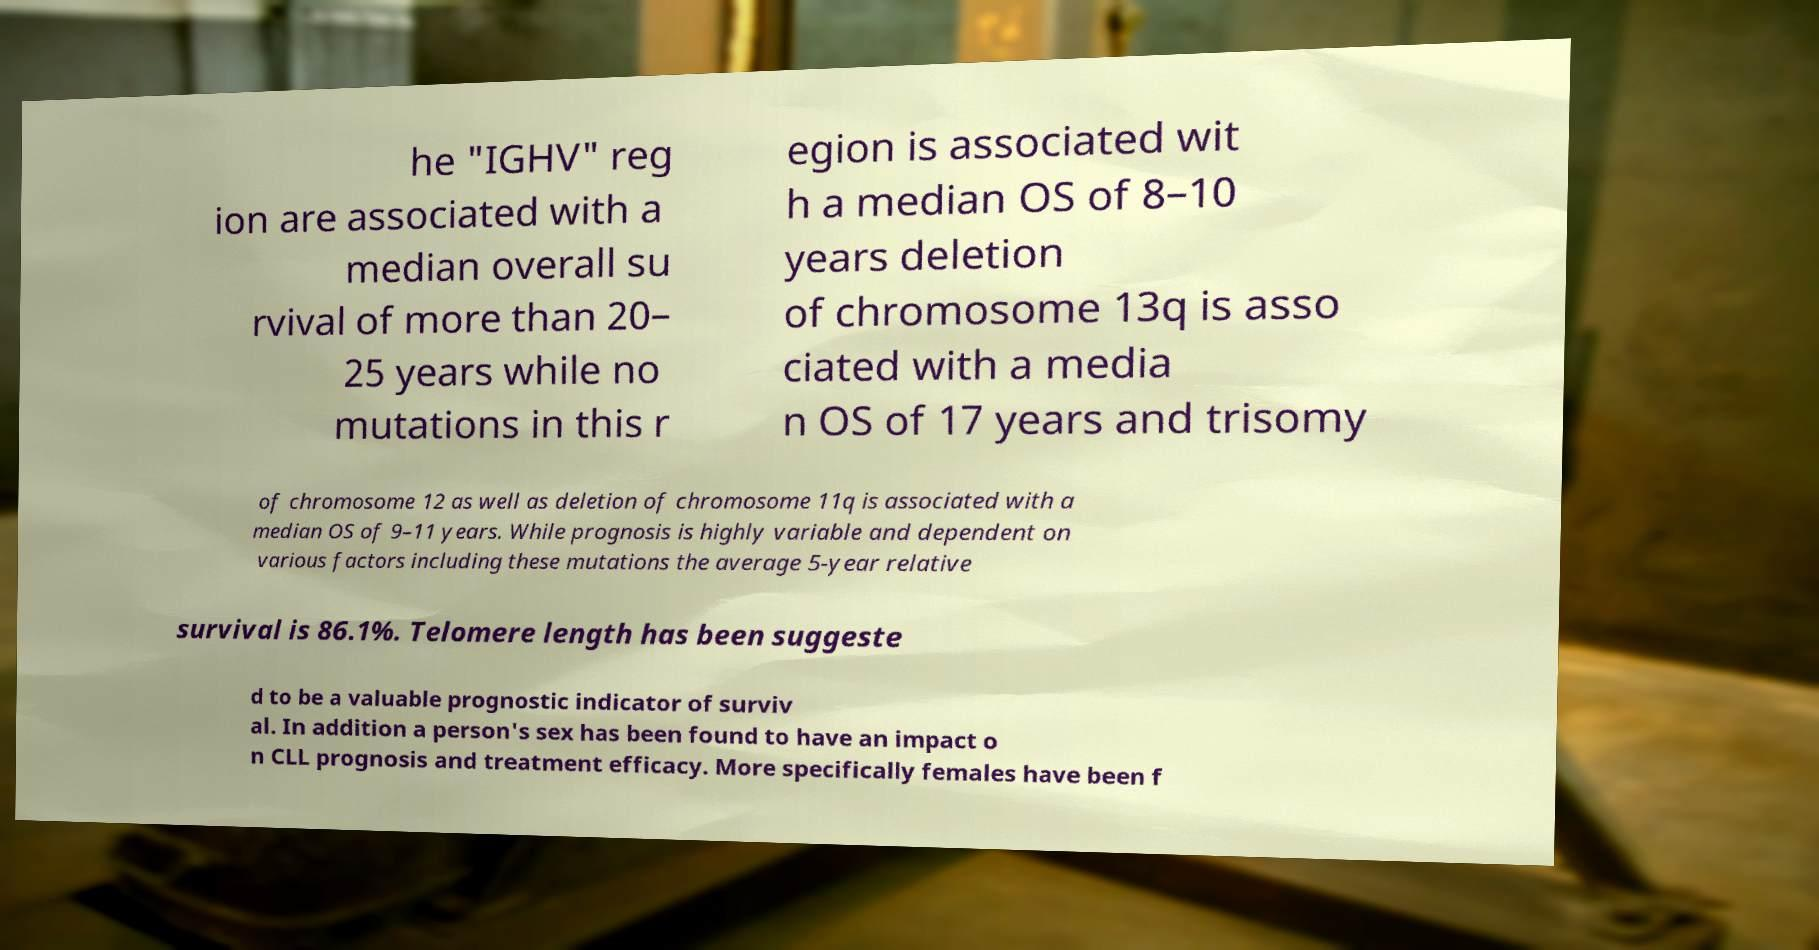Could you extract and type out the text from this image? he "IGHV" reg ion are associated with a median overall su rvival of more than 20– 25 years while no mutations in this r egion is associated wit h a median OS of 8–10 years deletion of chromosome 13q is asso ciated with a media n OS of 17 years and trisomy of chromosome 12 as well as deletion of chromosome 11q is associated with a median OS of 9–11 years. While prognosis is highly variable and dependent on various factors including these mutations the average 5-year relative survival is 86.1%. Telomere length has been suggeste d to be a valuable prognostic indicator of surviv al. In addition a person's sex has been found to have an impact o n CLL prognosis and treatment efficacy. More specifically females have been f 